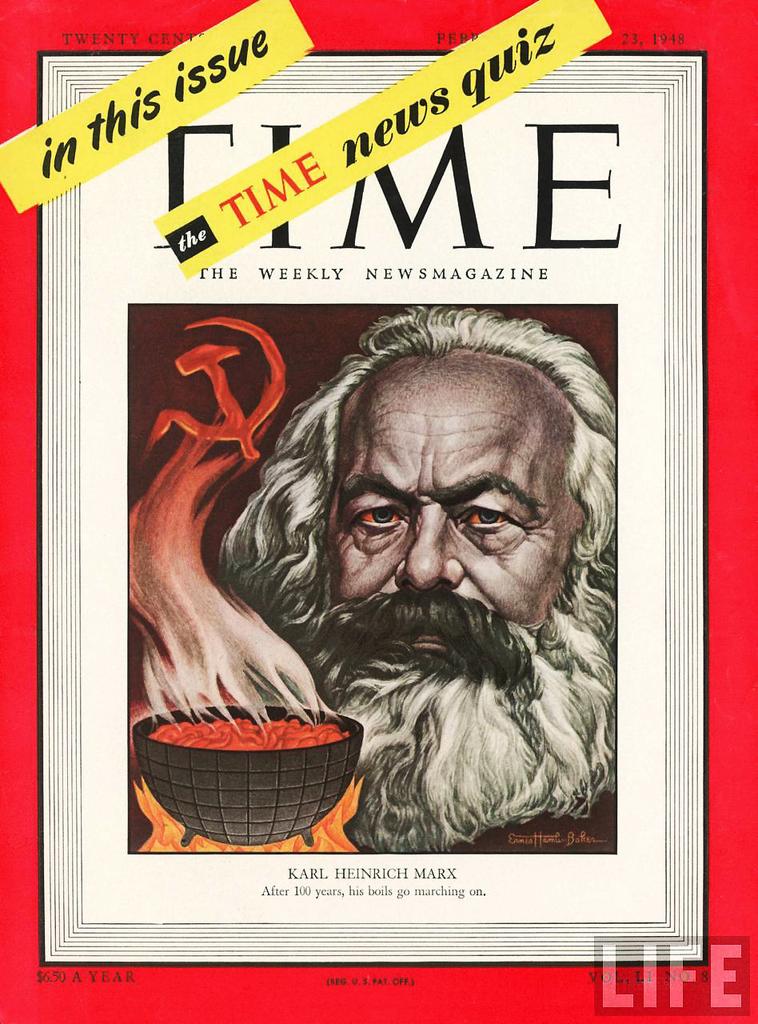Name this magazine?
Keep it short and to the point. Time. 